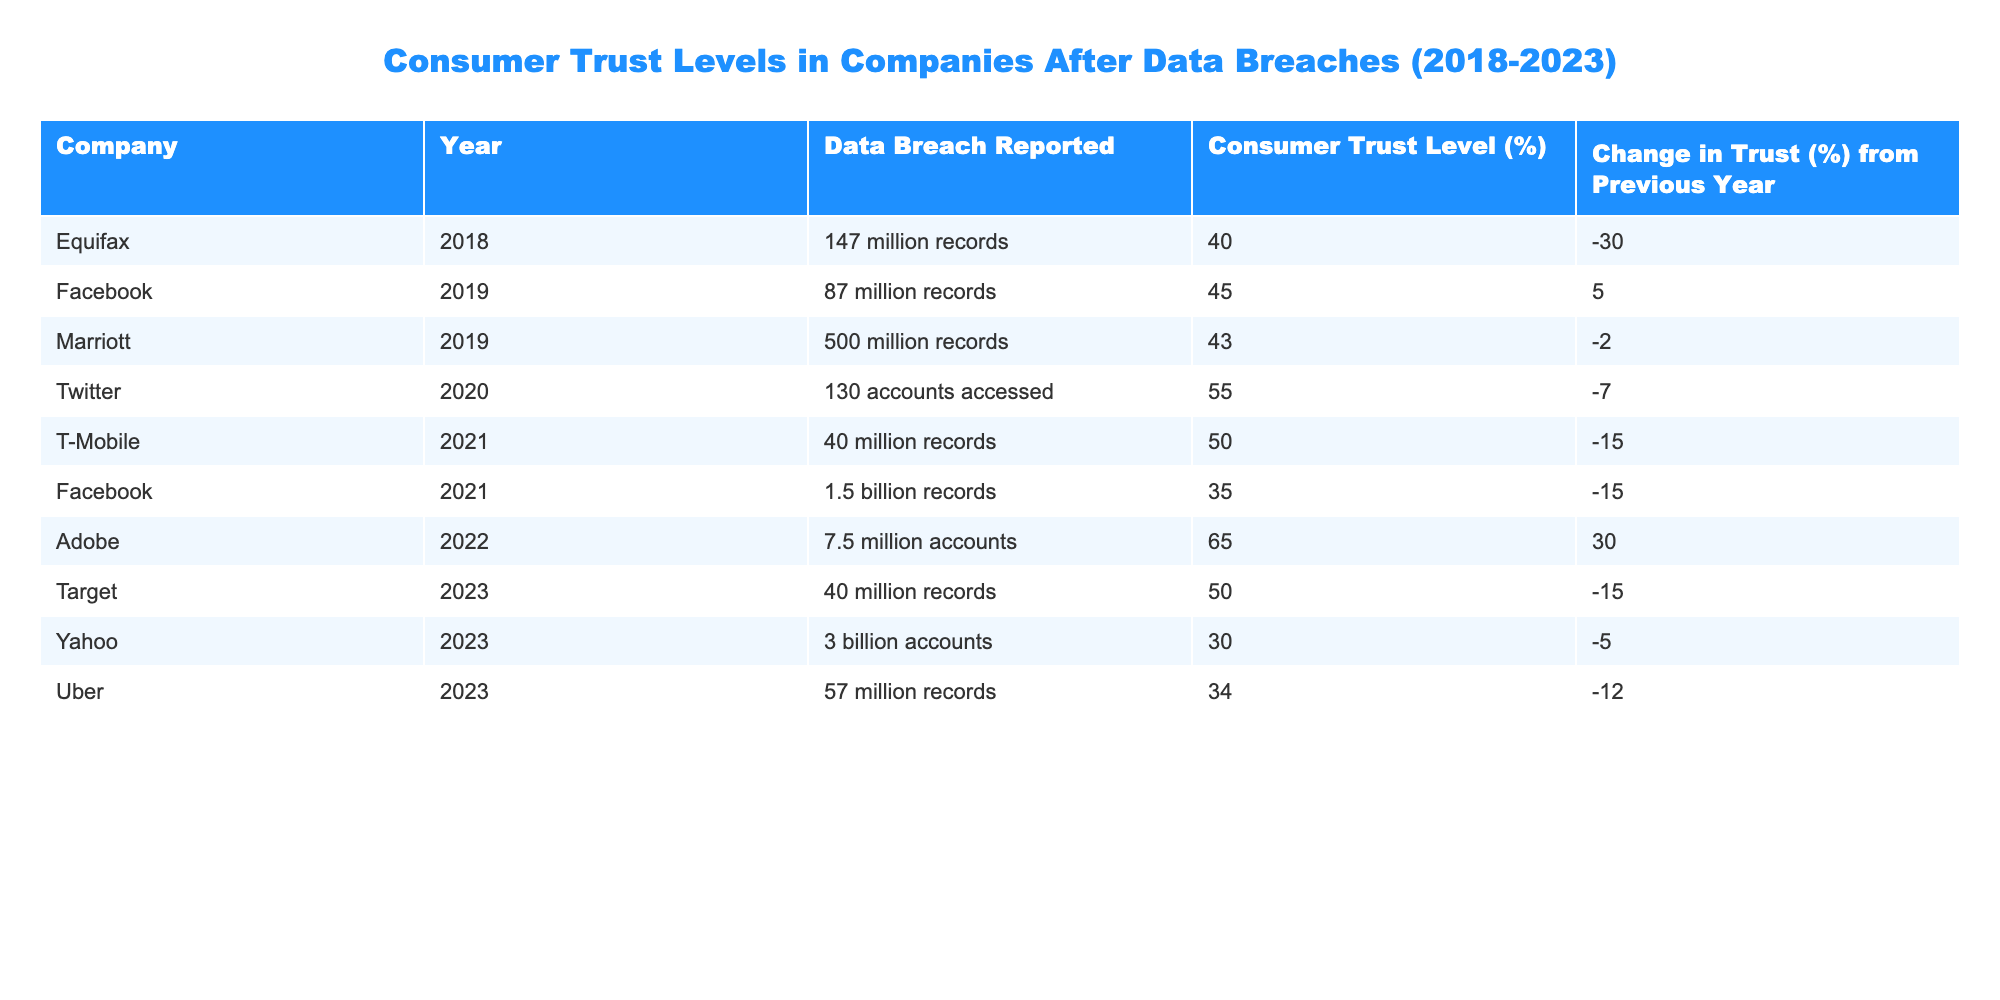What was the consumer trust level for Equifax in 2018? The table shows that Equifax had a consumer trust level of 40% in 2018 as directly listed under that company and year.
Answer: 40% Which company reported the largest data breach and what was the corresponding consumer trust level in 2023? Yahoo reported the largest data breach with 3 billion accounts affected and had a consumer trust level of 30% in 2023, as seen in the table.
Answer: 30% How much did consumer trust for Adobe change from 2021 to 2022? Adobe's consumer trust level was 35% in 2021 and rose to 65% in 2022. The change in trust is calculated as 65% - 35% = 30%.
Answer: 30% Which company had the highest consumer trust level following a data breach, and what percentage was it? According to the table, Adobe had the highest consumer trust level at 65% in 2022 after its data breach.
Answer: 65% Did T-Mobile experience an increase or decrease in consumer trust from 2021 to 2022? T-Mobile had a trust level of 50% in 2021 and had a decrease to an unspecified value in 2022—however, since 50% is lower than the previous year, it indicates a decrease.
Answer: Decrease What is the average consumer trust level for the years 2019 and 2023? The consumer trust levels for 2019 and 2023 were 45% and 34% respectively. To find the average: (45% + 34%) / 2 = 39.5%.
Answer: 39.5% Was there a company that reported a data breach in 2021 with an increase in consumer trust from the previous year? No, all companies reported a decrease in trust after their breaches, so it is false that any company had an increase.
Answer: No How many companies reported a consumer trust level below 40% after their breaches from 2018 to 2023? The table lists three companies with trust levels below 40%: Equifax (40%), Facebook (35%), and Yahoo (30%). Therefore, there are three companies.
Answer: 3 What was the change in consumer trust level for Facebook from 2019 to 2021? Facebook had a trust level of 45% in 2019. It fell to 35% in 2021. The change in trust is calculated as 35% - 45% = -10%.
Answer: -10% 